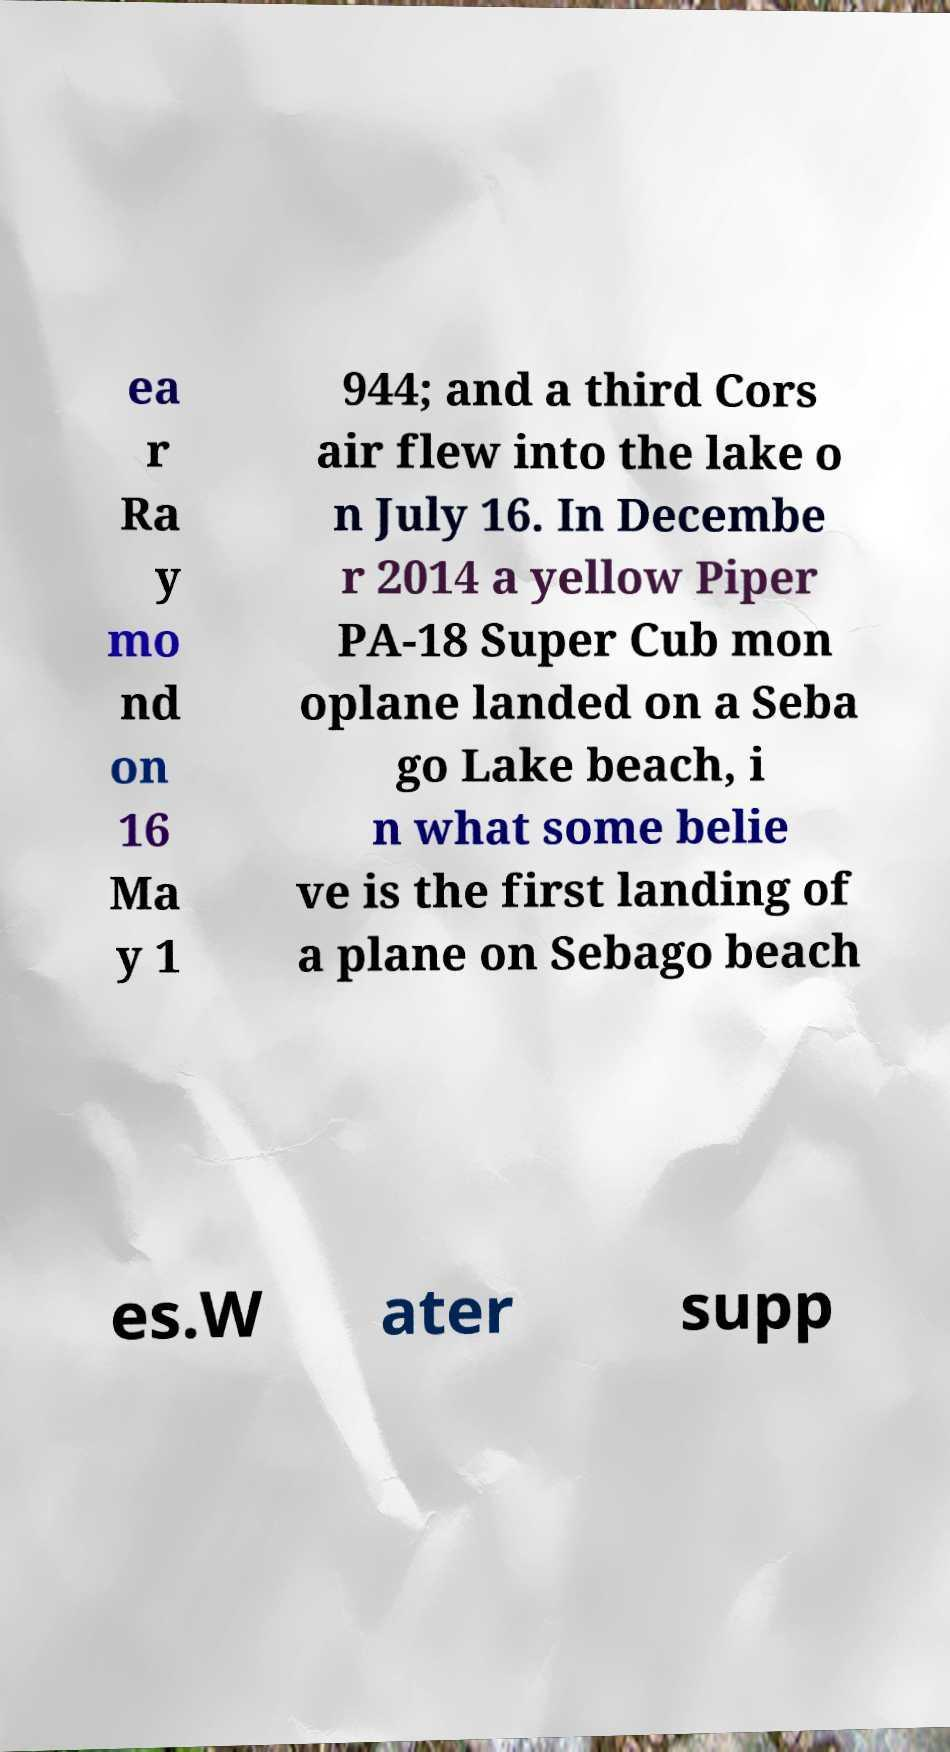Please identify and transcribe the text found in this image. ea r Ra y mo nd on 16 Ma y 1 944; and a third Cors air flew into the lake o n July 16. In Decembe r 2014 a yellow Piper PA-18 Super Cub mon oplane landed on a Seba go Lake beach, i n what some belie ve is the first landing of a plane on Sebago beach es.W ater supp 